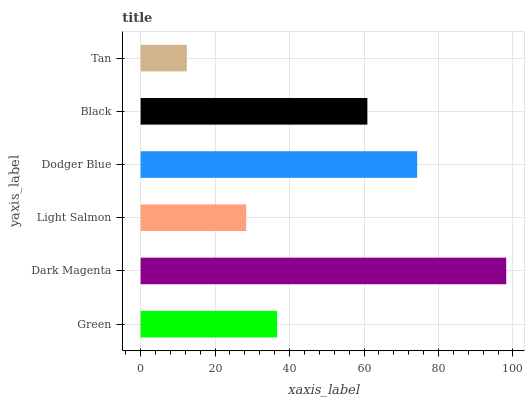Is Tan the minimum?
Answer yes or no. Yes. Is Dark Magenta the maximum?
Answer yes or no. Yes. Is Light Salmon the minimum?
Answer yes or no. No. Is Light Salmon the maximum?
Answer yes or no. No. Is Dark Magenta greater than Light Salmon?
Answer yes or no. Yes. Is Light Salmon less than Dark Magenta?
Answer yes or no. Yes. Is Light Salmon greater than Dark Magenta?
Answer yes or no. No. Is Dark Magenta less than Light Salmon?
Answer yes or no. No. Is Black the high median?
Answer yes or no. Yes. Is Green the low median?
Answer yes or no. Yes. Is Green the high median?
Answer yes or no. No. Is Dodger Blue the low median?
Answer yes or no. No. 